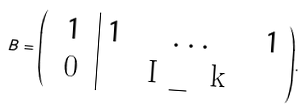<formula> <loc_0><loc_0><loc_500><loc_500>B = { \left ( \begin{array} { c | c c c } 1 & 1 & \dots & 1 \\ $ 0 $ & & $ I _ { k } $ & \end{array} \right ) } .</formula> 